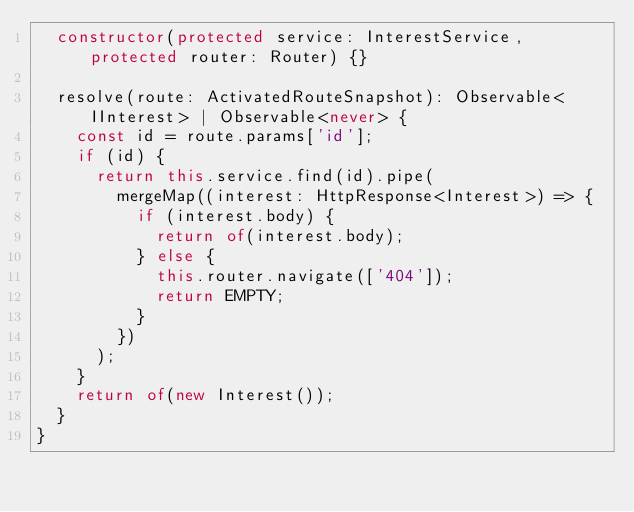Convert code to text. <code><loc_0><loc_0><loc_500><loc_500><_TypeScript_>  constructor(protected service: InterestService, protected router: Router) {}

  resolve(route: ActivatedRouteSnapshot): Observable<IInterest> | Observable<never> {
    const id = route.params['id'];
    if (id) {
      return this.service.find(id).pipe(
        mergeMap((interest: HttpResponse<Interest>) => {
          if (interest.body) {
            return of(interest.body);
          } else {
            this.router.navigate(['404']);
            return EMPTY;
          }
        })
      );
    }
    return of(new Interest());
  }
}
</code> 